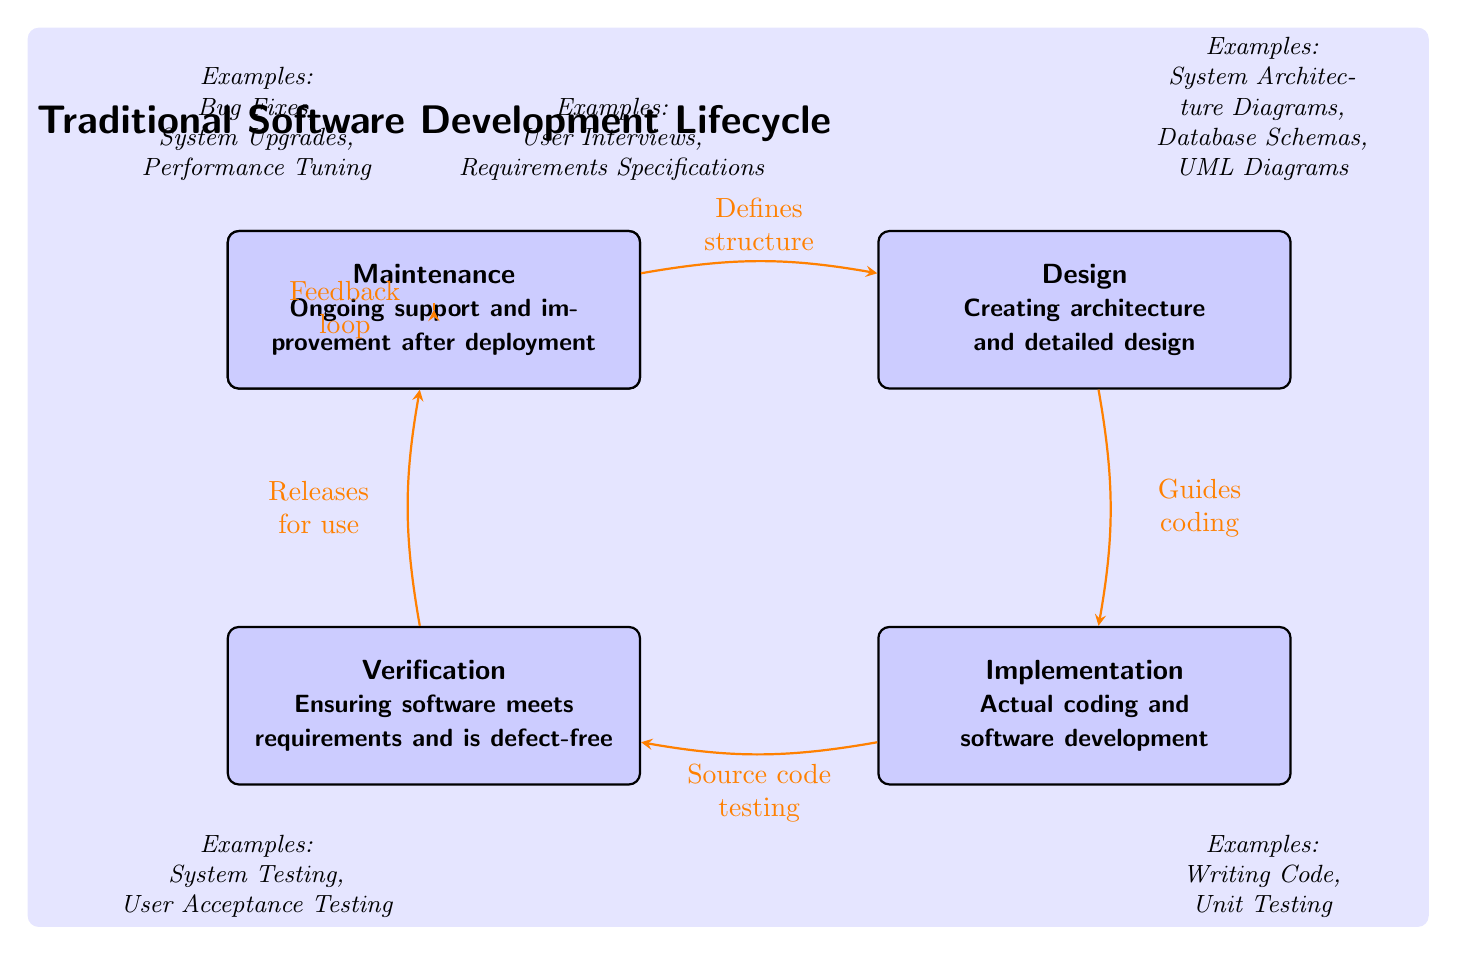What are the five phases in the Traditional Software Development Lifecycle? The diagram explicitly lists five phases: Requirements, Design, Implementation, Verification, and Maintenance.
Answer: Requirements, Design, Implementation, Verification, Maintenance Which phase involves actual coding and software development? The diagram indicates that the phase labeled Implementation is focused on actual coding and software development, as described in the text inside the node.
Answer: Implementation What is the feedback loop in the diagram associated with? The diagram illustrates that the feedback loop leads from the Maintenance phase back to the Requirements phase, suggesting that ongoing support and improvements can influence future requirements.
Answer: Requirements How many arrows are shown in the diagram connecting the phases? By visually counting the arrows connecting the phases, there are five arrows drawn in the diagram. Each arrow indicates a flow from one phase to the next.
Answer: Five What does the Design phase guide? According to the diagram, the arrow from the Design phase to the Implementation phase specifies that Design guides coding, reflecting the role of the design in directing the subsequent coding process.
Answer: Coding Which phase is responsible for ensuring the software meets requirements? The diagram clearly states that the Verification phase is responsible for ensuring the software meets the requirements and is defect-free, as mentioned in the description inside the node.
Answer: Verification What examples does the Requirements phase provide? The Requirements phase includes examples such as User Interviews and Requirements Specifications, as indicated by the note positioned near the corresponding phase in the diagram.
Answer: User Interviews, Requirements Specifications What type of testing is associated with the Implementation phase? The diagram indicates that the Implementation phase includes writing code and also specifies a component of unit testing, which refers to a type of testing that checks individual components for correctness.
Answer: Unit Testing Which phase is shown above the Verification phase? In the diagram, the Maintenance phase is positioned directly above the Verification phase, indicating its sequential relationship within the software development lifecycle.
Answer: Maintenance 